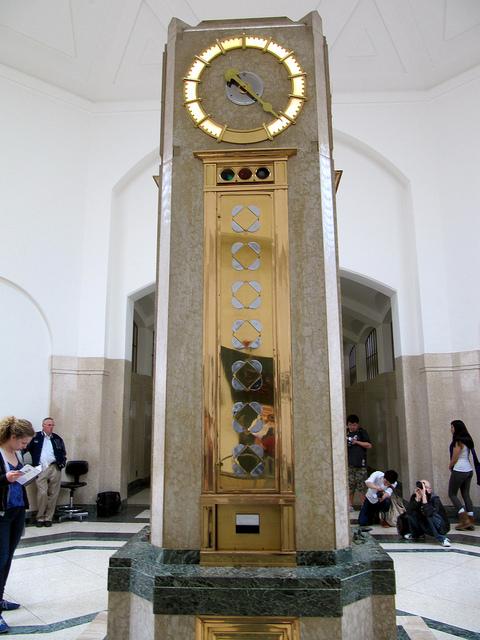What is the tower for?
Quick response, please. Telling time. Is the clock old?
Short answer required. Yes. What time does the clock read?
Be succinct. 10:21. Is this indoors?
Short answer required. Yes. 